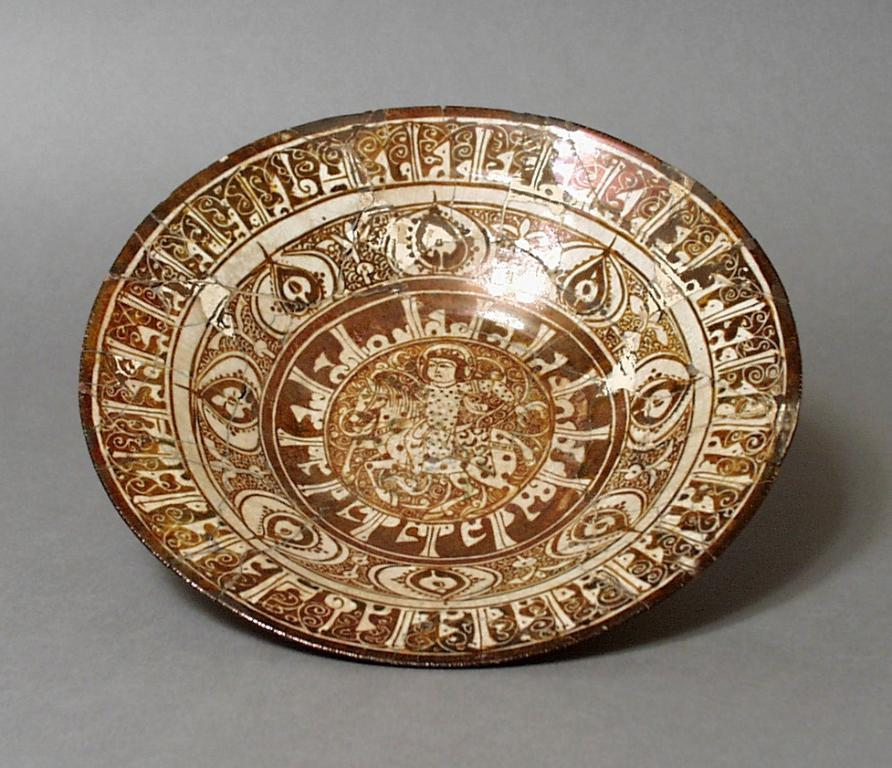What object can be seen in the image? There is a plate in the image. What can be observed in the background of the image? The background of the image is plain. What type of trail can be seen in the image? There is no trail present in the image. What does the plate smell like in the image? The image does not provide any information about the smell of the plate. 